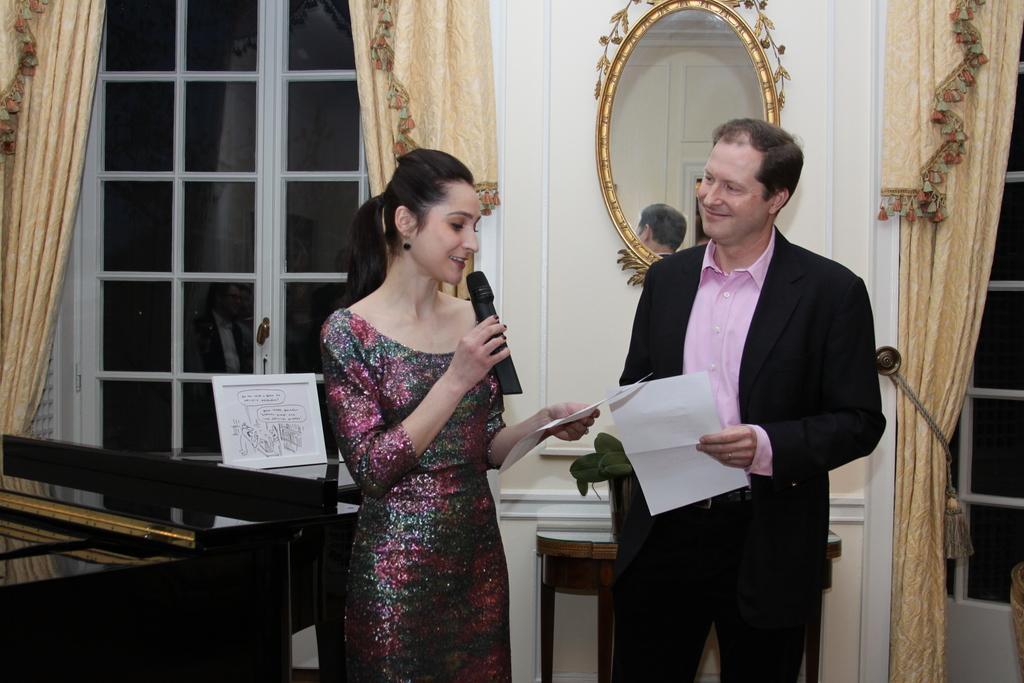In one or two sentences, can you explain what this image depicts? In this image in the center there is one man and one woman standing, and man is holding papers and woman is holding papers, mike and reading. And in the background there are tables, board, mirror, windows, curtains and wall. 